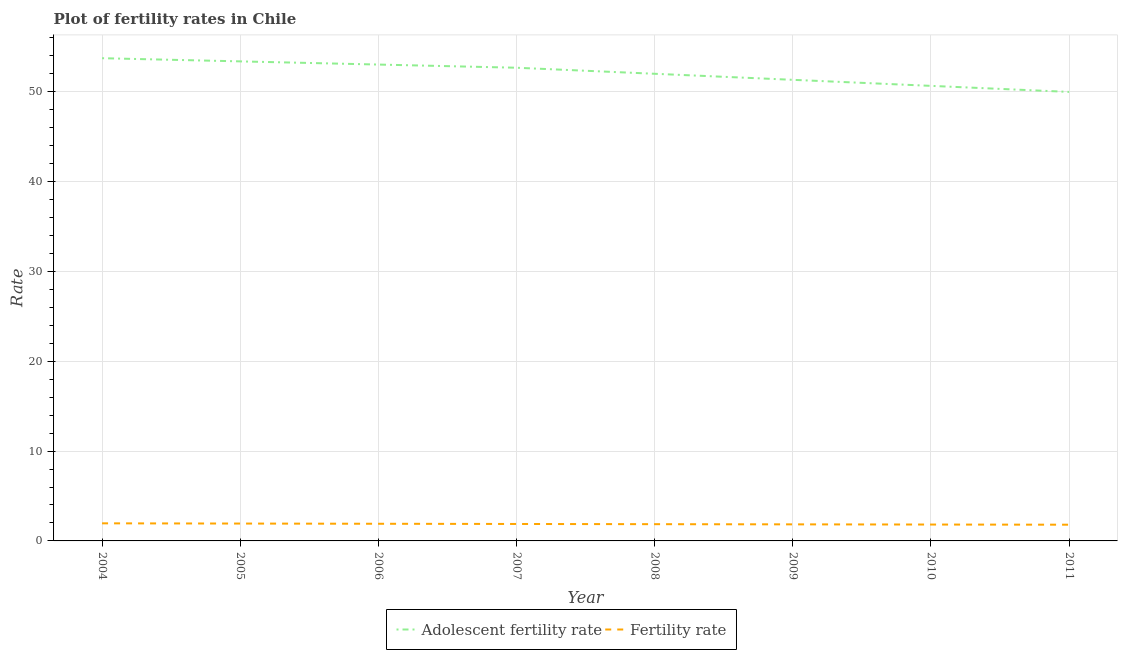Does the line corresponding to fertility rate intersect with the line corresponding to adolescent fertility rate?
Give a very brief answer. No. Is the number of lines equal to the number of legend labels?
Your answer should be compact. Yes. What is the fertility rate in 2008?
Provide a succinct answer. 1.86. Across all years, what is the maximum adolescent fertility rate?
Keep it short and to the point. 53.75. Across all years, what is the minimum adolescent fertility rate?
Ensure brevity in your answer.  49.99. In which year was the fertility rate maximum?
Provide a short and direct response. 2004. In which year was the adolescent fertility rate minimum?
Offer a terse response. 2011. What is the total adolescent fertility rate in the graph?
Offer a terse response. 416.87. What is the difference between the adolescent fertility rate in 2009 and that in 2010?
Give a very brief answer. 0.67. What is the difference between the adolescent fertility rate in 2007 and the fertility rate in 2008?
Provide a succinct answer. 50.82. What is the average fertility rate per year?
Ensure brevity in your answer.  1.88. In the year 2006, what is the difference between the adolescent fertility rate and fertility rate?
Your answer should be compact. 51.13. In how many years, is the fertility rate greater than 34?
Your answer should be compact. 0. What is the ratio of the adolescent fertility rate in 2009 to that in 2010?
Your answer should be very brief. 1.01. Is the difference between the adolescent fertility rate in 2007 and 2010 greater than the difference between the fertility rate in 2007 and 2010?
Offer a terse response. Yes. What is the difference between the highest and the second highest fertility rate?
Your answer should be very brief. 0.03. What is the difference between the highest and the lowest adolescent fertility rate?
Give a very brief answer. 3.75. Is the fertility rate strictly greater than the adolescent fertility rate over the years?
Keep it short and to the point. No. What is the difference between two consecutive major ticks on the Y-axis?
Your answer should be compact. 10. Are the values on the major ticks of Y-axis written in scientific E-notation?
Offer a very short reply. No. Does the graph contain any zero values?
Your response must be concise. No. Does the graph contain grids?
Offer a terse response. Yes. How are the legend labels stacked?
Ensure brevity in your answer.  Horizontal. What is the title of the graph?
Ensure brevity in your answer.  Plot of fertility rates in Chile. What is the label or title of the X-axis?
Make the answer very short. Year. What is the label or title of the Y-axis?
Offer a terse response. Rate. What is the Rate of Adolescent fertility rate in 2004?
Ensure brevity in your answer.  53.75. What is the Rate in Fertility rate in 2004?
Your answer should be compact. 1.96. What is the Rate of Adolescent fertility rate in 2005?
Provide a short and direct response. 53.39. What is the Rate in Fertility rate in 2005?
Provide a succinct answer. 1.93. What is the Rate in Adolescent fertility rate in 2006?
Your answer should be very brief. 53.04. What is the Rate in Fertility rate in 2006?
Give a very brief answer. 1.91. What is the Rate in Adolescent fertility rate in 2007?
Provide a succinct answer. 52.69. What is the Rate in Fertility rate in 2007?
Your response must be concise. 1.89. What is the Rate of Adolescent fertility rate in 2008?
Your answer should be compact. 52.01. What is the Rate of Fertility rate in 2008?
Your answer should be compact. 1.86. What is the Rate of Adolescent fertility rate in 2009?
Make the answer very short. 51.34. What is the Rate of Fertility rate in 2009?
Your answer should be very brief. 1.84. What is the Rate in Adolescent fertility rate in 2010?
Your answer should be compact. 50.67. What is the Rate in Fertility rate in 2010?
Give a very brief answer. 1.82. What is the Rate of Adolescent fertility rate in 2011?
Your answer should be compact. 49.99. What is the Rate in Fertility rate in 2011?
Offer a terse response. 1.81. Across all years, what is the maximum Rate in Adolescent fertility rate?
Keep it short and to the point. 53.75. Across all years, what is the maximum Rate in Fertility rate?
Your answer should be compact. 1.96. Across all years, what is the minimum Rate in Adolescent fertility rate?
Give a very brief answer. 49.99. Across all years, what is the minimum Rate in Fertility rate?
Offer a very short reply. 1.81. What is the total Rate of Adolescent fertility rate in the graph?
Your answer should be very brief. 416.87. What is the total Rate of Fertility rate in the graph?
Ensure brevity in your answer.  15.03. What is the difference between the Rate of Adolescent fertility rate in 2004 and that in 2005?
Provide a short and direct response. 0.35. What is the difference between the Rate of Fertility rate in 2004 and that in 2005?
Make the answer very short. 0.03. What is the difference between the Rate of Adolescent fertility rate in 2004 and that in 2006?
Offer a very short reply. 0.71. What is the difference between the Rate of Fertility rate in 2004 and that in 2006?
Provide a short and direct response. 0.05. What is the difference between the Rate in Adolescent fertility rate in 2004 and that in 2007?
Your answer should be very brief. 1.06. What is the difference between the Rate of Fertility rate in 2004 and that in 2007?
Provide a succinct answer. 0.07. What is the difference between the Rate of Adolescent fertility rate in 2004 and that in 2008?
Provide a short and direct response. 1.73. What is the difference between the Rate in Fertility rate in 2004 and that in 2008?
Ensure brevity in your answer.  0.09. What is the difference between the Rate of Adolescent fertility rate in 2004 and that in 2009?
Make the answer very short. 2.41. What is the difference between the Rate in Fertility rate in 2004 and that in 2009?
Offer a terse response. 0.12. What is the difference between the Rate in Adolescent fertility rate in 2004 and that in 2010?
Offer a very short reply. 3.08. What is the difference between the Rate in Fertility rate in 2004 and that in 2010?
Offer a very short reply. 0.14. What is the difference between the Rate in Adolescent fertility rate in 2004 and that in 2011?
Provide a short and direct response. 3.75. What is the difference between the Rate in Fertility rate in 2004 and that in 2011?
Your response must be concise. 0.15. What is the difference between the Rate in Adolescent fertility rate in 2005 and that in 2006?
Give a very brief answer. 0.35. What is the difference between the Rate in Fertility rate in 2005 and that in 2006?
Keep it short and to the point. 0.02. What is the difference between the Rate in Adolescent fertility rate in 2005 and that in 2007?
Offer a terse response. 0.71. What is the difference between the Rate of Fertility rate in 2005 and that in 2007?
Provide a succinct answer. 0.05. What is the difference between the Rate of Adolescent fertility rate in 2005 and that in 2008?
Keep it short and to the point. 1.38. What is the difference between the Rate of Fertility rate in 2005 and that in 2008?
Make the answer very short. 0.07. What is the difference between the Rate of Adolescent fertility rate in 2005 and that in 2009?
Provide a succinct answer. 2.05. What is the difference between the Rate of Fertility rate in 2005 and that in 2009?
Provide a short and direct response. 0.09. What is the difference between the Rate of Adolescent fertility rate in 2005 and that in 2010?
Your answer should be compact. 2.73. What is the difference between the Rate in Fertility rate in 2005 and that in 2010?
Make the answer very short. 0.11. What is the difference between the Rate of Adolescent fertility rate in 2005 and that in 2011?
Ensure brevity in your answer.  3.4. What is the difference between the Rate of Fertility rate in 2005 and that in 2011?
Provide a short and direct response. 0.13. What is the difference between the Rate in Adolescent fertility rate in 2006 and that in 2007?
Your response must be concise. 0.35. What is the difference between the Rate of Fertility rate in 2006 and that in 2007?
Ensure brevity in your answer.  0.02. What is the difference between the Rate in Adolescent fertility rate in 2006 and that in 2008?
Your answer should be compact. 1.03. What is the difference between the Rate in Fertility rate in 2006 and that in 2008?
Your answer should be very brief. 0.04. What is the difference between the Rate in Adolescent fertility rate in 2006 and that in 2009?
Your answer should be compact. 1.7. What is the difference between the Rate of Fertility rate in 2006 and that in 2009?
Give a very brief answer. 0.07. What is the difference between the Rate of Adolescent fertility rate in 2006 and that in 2010?
Keep it short and to the point. 2.37. What is the difference between the Rate in Fertility rate in 2006 and that in 2010?
Provide a short and direct response. 0.09. What is the difference between the Rate in Adolescent fertility rate in 2006 and that in 2011?
Your answer should be compact. 3.05. What is the difference between the Rate in Fertility rate in 2006 and that in 2011?
Provide a succinct answer. 0.1. What is the difference between the Rate of Adolescent fertility rate in 2007 and that in 2008?
Provide a succinct answer. 0.67. What is the difference between the Rate of Fertility rate in 2007 and that in 2008?
Your answer should be very brief. 0.02. What is the difference between the Rate in Adolescent fertility rate in 2007 and that in 2009?
Your answer should be compact. 1.35. What is the difference between the Rate of Fertility rate in 2007 and that in 2009?
Keep it short and to the point. 0.04. What is the difference between the Rate of Adolescent fertility rate in 2007 and that in 2010?
Provide a succinct answer. 2.02. What is the difference between the Rate of Fertility rate in 2007 and that in 2010?
Provide a succinct answer. 0.06. What is the difference between the Rate of Adolescent fertility rate in 2007 and that in 2011?
Your answer should be compact. 2.69. What is the difference between the Rate in Fertility rate in 2007 and that in 2011?
Keep it short and to the point. 0.08. What is the difference between the Rate in Adolescent fertility rate in 2008 and that in 2009?
Ensure brevity in your answer.  0.67. What is the difference between the Rate of Fertility rate in 2008 and that in 2009?
Offer a terse response. 0.02. What is the difference between the Rate of Adolescent fertility rate in 2008 and that in 2010?
Give a very brief answer. 1.35. What is the difference between the Rate of Fertility rate in 2008 and that in 2010?
Your response must be concise. 0.04. What is the difference between the Rate in Adolescent fertility rate in 2008 and that in 2011?
Keep it short and to the point. 2.02. What is the difference between the Rate in Fertility rate in 2008 and that in 2011?
Provide a succinct answer. 0.06. What is the difference between the Rate of Adolescent fertility rate in 2009 and that in 2010?
Offer a terse response. 0.67. What is the difference between the Rate of Adolescent fertility rate in 2009 and that in 2011?
Offer a very short reply. 1.35. What is the difference between the Rate of Fertility rate in 2009 and that in 2011?
Your response must be concise. 0.04. What is the difference between the Rate in Adolescent fertility rate in 2010 and that in 2011?
Give a very brief answer. 0.67. What is the difference between the Rate of Fertility rate in 2010 and that in 2011?
Your answer should be compact. 0.02. What is the difference between the Rate in Adolescent fertility rate in 2004 and the Rate in Fertility rate in 2005?
Offer a terse response. 51.81. What is the difference between the Rate of Adolescent fertility rate in 2004 and the Rate of Fertility rate in 2006?
Offer a terse response. 51.84. What is the difference between the Rate in Adolescent fertility rate in 2004 and the Rate in Fertility rate in 2007?
Give a very brief answer. 51.86. What is the difference between the Rate of Adolescent fertility rate in 2004 and the Rate of Fertility rate in 2008?
Offer a very short reply. 51.88. What is the difference between the Rate in Adolescent fertility rate in 2004 and the Rate in Fertility rate in 2009?
Your answer should be compact. 51.9. What is the difference between the Rate of Adolescent fertility rate in 2004 and the Rate of Fertility rate in 2010?
Your answer should be very brief. 51.92. What is the difference between the Rate in Adolescent fertility rate in 2004 and the Rate in Fertility rate in 2011?
Your answer should be very brief. 51.94. What is the difference between the Rate of Adolescent fertility rate in 2005 and the Rate of Fertility rate in 2006?
Your answer should be very brief. 51.48. What is the difference between the Rate of Adolescent fertility rate in 2005 and the Rate of Fertility rate in 2007?
Give a very brief answer. 51.51. What is the difference between the Rate in Adolescent fertility rate in 2005 and the Rate in Fertility rate in 2008?
Keep it short and to the point. 51.53. What is the difference between the Rate in Adolescent fertility rate in 2005 and the Rate in Fertility rate in 2009?
Your answer should be very brief. 51.55. What is the difference between the Rate in Adolescent fertility rate in 2005 and the Rate in Fertility rate in 2010?
Your answer should be compact. 51.57. What is the difference between the Rate of Adolescent fertility rate in 2005 and the Rate of Fertility rate in 2011?
Offer a terse response. 51.59. What is the difference between the Rate of Adolescent fertility rate in 2006 and the Rate of Fertility rate in 2007?
Offer a very short reply. 51.15. What is the difference between the Rate of Adolescent fertility rate in 2006 and the Rate of Fertility rate in 2008?
Your answer should be compact. 51.17. What is the difference between the Rate in Adolescent fertility rate in 2006 and the Rate in Fertility rate in 2009?
Offer a terse response. 51.19. What is the difference between the Rate in Adolescent fertility rate in 2006 and the Rate in Fertility rate in 2010?
Make the answer very short. 51.21. What is the difference between the Rate in Adolescent fertility rate in 2006 and the Rate in Fertility rate in 2011?
Your answer should be compact. 51.23. What is the difference between the Rate in Adolescent fertility rate in 2007 and the Rate in Fertility rate in 2008?
Offer a terse response. 50.82. What is the difference between the Rate of Adolescent fertility rate in 2007 and the Rate of Fertility rate in 2009?
Make the answer very short. 50.84. What is the difference between the Rate in Adolescent fertility rate in 2007 and the Rate in Fertility rate in 2010?
Your answer should be very brief. 50.86. What is the difference between the Rate of Adolescent fertility rate in 2007 and the Rate of Fertility rate in 2011?
Your answer should be compact. 50.88. What is the difference between the Rate of Adolescent fertility rate in 2008 and the Rate of Fertility rate in 2009?
Your answer should be very brief. 50.17. What is the difference between the Rate in Adolescent fertility rate in 2008 and the Rate in Fertility rate in 2010?
Ensure brevity in your answer.  50.19. What is the difference between the Rate of Adolescent fertility rate in 2008 and the Rate of Fertility rate in 2011?
Provide a short and direct response. 50.21. What is the difference between the Rate of Adolescent fertility rate in 2009 and the Rate of Fertility rate in 2010?
Make the answer very short. 49.52. What is the difference between the Rate of Adolescent fertility rate in 2009 and the Rate of Fertility rate in 2011?
Ensure brevity in your answer.  49.53. What is the difference between the Rate in Adolescent fertility rate in 2010 and the Rate in Fertility rate in 2011?
Provide a succinct answer. 48.86. What is the average Rate of Adolescent fertility rate per year?
Offer a very short reply. 52.11. What is the average Rate in Fertility rate per year?
Make the answer very short. 1.88. In the year 2004, what is the difference between the Rate in Adolescent fertility rate and Rate in Fertility rate?
Keep it short and to the point. 51.79. In the year 2005, what is the difference between the Rate of Adolescent fertility rate and Rate of Fertility rate?
Ensure brevity in your answer.  51.46. In the year 2006, what is the difference between the Rate of Adolescent fertility rate and Rate of Fertility rate?
Give a very brief answer. 51.13. In the year 2007, what is the difference between the Rate of Adolescent fertility rate and Rate of Fertility rate?
Provide a succinct answer. 50.8. In the year 2008, what is the difference between the Rate of Adolescent fertility rate and Rate of Fertility rate?
Your answer should be compact. 50.15. In the year 2009, what is the difference between the Rate of Adolescent fertility rate and Rate of Fertility rate?
Provide a short and direct response. 49.49. In the year 2010, what is the difference between the Rate in Adolescent fertility rate and Rate in Fertility rate?
Your answer should be compact. 48.84. In the year 2011, what is the difference between the Rate in Adolescent fertility rate and Rate in Fertility rate?
Give a very brief answer. 48.19. What is the ratio of the Rate of Adolescent fertility rate in 2004 to that in 2005?
Provide a succinct answer. 1.01. What is the ratio of the Rate of Fertility rate in 2004 to that in 2005?
Provide a succinct answer. 1.01. What is the ratio of the Rate of Adolescent fertility rate in 2004 to that in 2006?
Offer a very short reply. 1.01. What is the ratio of the Rate of Fertility rate in 2004 to that in 2006?
Make the answer very short. 1.03. What is the ratio of the Rate of Adolescent fertility rate in 2004 to that in 2007?
Offer a very short reply. 1.02. What is the ratio of the Rate in Fertility rate in 2004 to that in 2007?
Make the answer very short. 1.04. What is the ratio of the Rate in Adolescent fertility rate in 2004 to that in 2008?
Your answer should be very brief. 1.03. What is the ratio of the Rate of Fertility rate in 2004 to that in 2008?
Make the answer very short. 1.05. What is the ratio of the Rate in Adolescent fertility rate in 2004 to that in 2009?
Your answer should be very brief. 1.05. What is the ratio of the Rate of Fertility rate in 2004 to that in 2009?
Offer a very short reply. 1.06. What is the ratio of the Rate of Adolescent fertility rate in 2004 to that in 2010?
Your answer should be compact. 1.06. What is the ratio of the Rate of Fertility rate in 2004 to that in 2010?
Offer a very short reply. 1.07. What is the ratio of the Rate of Adolescent fertility rate in 2004 to that in 2011?
Your answer should be compact. 1.08. What is the ratio of the Rate in Fertility rate in 2004 to that in 2011?
Provide a succinct answer. 1.08. What is the ratio of the Rate in Fertility rate in 2005 to that in 2006?
Your answer should be compact. 1.01. What is the ratio of the Rate in Adolescent fertility rate in 2005 to that in 2007?
Your answer should be very brief. 1.01. What is the ratio of the Rate in Fertility rate in 2005 to that in 2007?
Make the answer very short. 1.02. What is the ratio of the Rate of Adolescent fertility rate in 2005 to that in 2008?
Ensure brevity in your answer.  1.03. What is the ratio of the Rate in Adolescent fertility rate in 2005 to that in 2009?
Your answer should be very brief. 1.04. What is the ratio of the Rate in Fertility rate in 2005 to that in 2009?
Your answer should be compact. 1.05. What is the ratio of the Rate in Adolescent fertility rate in 2005 to that in 2010?
Make the answer very short. 1.05. What is the ratio of the Rate of Fertility rate in 2005 to that in 2010?
Keep it short and to the point. 1.06. What is the ratio of the Rate of Adolescent fertility rate in 2005 to that in 2011?
Your answer should be compact. 1.07. What is the ratio of the Rate of Fertility rate in 2005 to that in 2011?
Offer a very short reply. 1.07. What is the ratio of the Rate of Adolescent fertility rate in 2006 to that in 2007?
Make the answer very short. 1.01. What is the ratio of the Rate of Fertility rate in 2006 to that in 2007?
Make the answer very short. 1.01. What is the ratio of the Rate of Adolescent fertility rate in 2006 to that in 2008?
Give a very brief answer. 1.02. What is the ratio of the Rate of Fertility rate in 2006 to that in 2008?
Ensure brevity in your answer.  1.02. What is the ratio of the Rate in Adolescent fertility rate in 2006 to that in 2009?
Offer a very short reply. 1.03. What is the ratio of the Rate of Fertility rate in 2006 to that in 2009?
Ensure brevity in your answer.  1.04. What is the ratio of the Rate in Adolescent fertility rate in 2006 to that in 2010?
Make the answer very short. 1.05. What is the ratio of the Rate of Fertility rate in 2006 to that in 2010?
Offer a very short reply. 1.05. What is the ratio of the Rate in Adolescent fertility rate in 2006 to that in 2011?
Your answer should be very brief. 1.06. What is the ratio of the Rate in Fertility rate in 2006 to that in 2011?
Offer a terse response. 1.06. What is the ratio of the Rate of Adolescent fertility rate in 2007 to that in 2008?
Provide a short and direct response. 1.01. What is the ratio of the Rate of Fertility rate in 2007 to that in 2008?
Make the answer very short. 1.01. What is the ratio of the Rate in Adolescent fertility rate in 2007 to that in 2009?
Offer a very short reply. 1.03. What is the ratio of the Rate in Fertility rate in 2007 to that in 2009?
Make the answer very short. 1.02. What is the ratio of the Rate of Adolescent fertility rate in 2007 to that in 2010?
Your answer should be compact. 1.04. What is the ratio of the Rate of Fertility rate in 2007 to that in 2010?
Keep it short and to the point. 1.03. What is the ratio of the Rate of Adolescent fertility rate in 2007 to that in 2011?
Provide a short and direct response. 1.05. What is the ratio of the Rate in Fertility rate in 2007 to that in 2011?
Your answer should be very brief. 1.04. What is the ratio of the Rate in Adolescent fertility rate in 2008 to that in 2009?
Ensure brevity in your answer.  1.01. What is the ratio of the Rate of Fertility rate in 2008 to that in 2009?
Keep it short and to the point. 1.01. What is the ratio of the Rate in Adolescent fertility rate in 2008 to that in 2010?
Provide a succinct answer. 1.03. What is the ratio of the Rate of Fertility rate in 2008 to that in 2010?
Provide a succinct answer. 1.02. What is the ratio of the Rate in Adolescent fertility rate in 2008 to that in 2011?
Your answer should be very brief. 1.04. What is the ratio of the Rate in Fertility rate in 2008 to that in 2011?
Make the answer very short. 1.03. What is the ratio of the Rate of Adolescent fertility rate in 2009 to that in 2010?
Your answer should be very brief. 1.01. What is the ratio of the Rate in Adolescent fertility rate in 2009 to that in 2011?
Provide a short and direct response. 1.03. What is the ratio of the Rate in Adolescent fertility rate in 2010 to that in 2011?
Provide a succinct answer. 1.01. What is the ratio of the Rate in Fertility rate in 2010 to that in 2011?
Provide a succinct answer. 1.01. What is the difference between the highest and the second highest Rate of Adolescent fertility rate?
Offer a terse response. 0.35. What is the difference between the highest and the second highest Rate in Fertility rate?
Offer a very short reply. 0.03. What is the difference between the highest and the lowest Rate in Adolescent fertility rate?
Your answer should be compact. 3.75. What is the difference between the highest and the lowest Rate of Fertility rate?
Provide a short and direct response. 0.15. 